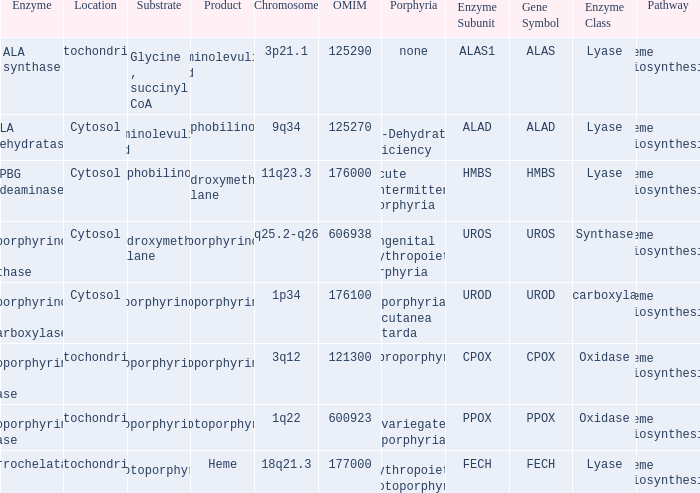Which substrate has an OMIM of 176000? Porphobilinogen. 